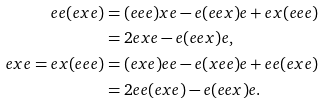Convert formula to latex. <formula><loc_0><loc_0><loc_500><loc_500>e e ( e x e ) & = ( e e e ) x e - e ( e e x ) e + e x ( e e e ) \\ & = 2 e x e - e ( e e x ) e , \\ e x e = e x ( e e e ) & = ( e x e ) e e - e ( x e e ) e + e e ( e x e ) \\ & = 2 e e ( e x e ) - e ( e e x ) e .</formula> 